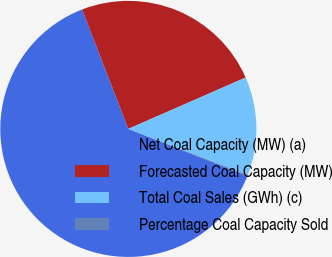<chart> <loc_0><loc_0><loc_500><loc_500><pie_chart><fcel>Net Coal Capacity (MW) (a)<fcel>Forecasted Coal Capacity (MW)<fcel>Total Coal Sales (GWh) (c)<fcel>Percentage Coal Capacity Sold<nl><fcel>63.13%<fcel>24.31%<fcel>12.44%<fcel>0.12%<nl></chart> 